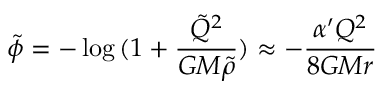<formula> <loc_0><loc_0><loc_500><loc_500>\tilde { \phi } = - \log { ( 1 + \frac { \tilde { Q } ^ { 2 } } { G M \tilde { \rho } } ) } \approx - \frac { \alpha ^ { \prime } Q ^ { 2 } } { 8 G M r }</formula> 